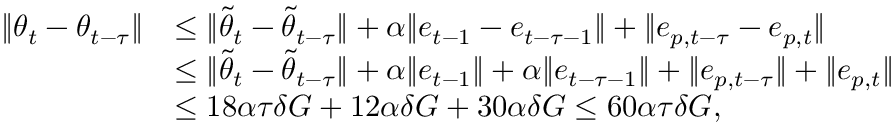<formula> <loc_0><loc_0><loc_500><loc_500>\begin{array} { r l } { \| { \theta } _ { t } - { \theta } _ { t - \tau } \| } & { \leq \| \tilde { \theta } _ { t } - \tilde { \theta } _ { t - \tau } \| + \alpha \| e _ { t - 1 } - e _ { t - \tau - 1 } \| + \| e _ { p , t - \tau } - e _ { p , t } \| } \\ & { \leq \| \tilde { \theta } _ { t } - \tilde { \theta } _ { t - \tau } \| + \alpha \| e _ { t - 1 } \| + \alpha \| e _ { t - \tau - 1 } \| + \| e _ { p , t - \tau } \| + \| e _ { p , t } \| } \\ & { \leq 1 8 \alpha \tau \delta G + 1 2 \alpha \delta G + 3 0 \alpha \delta G \leq 6 0 \alpha \tau \delta G , } \end{array}</formula> 